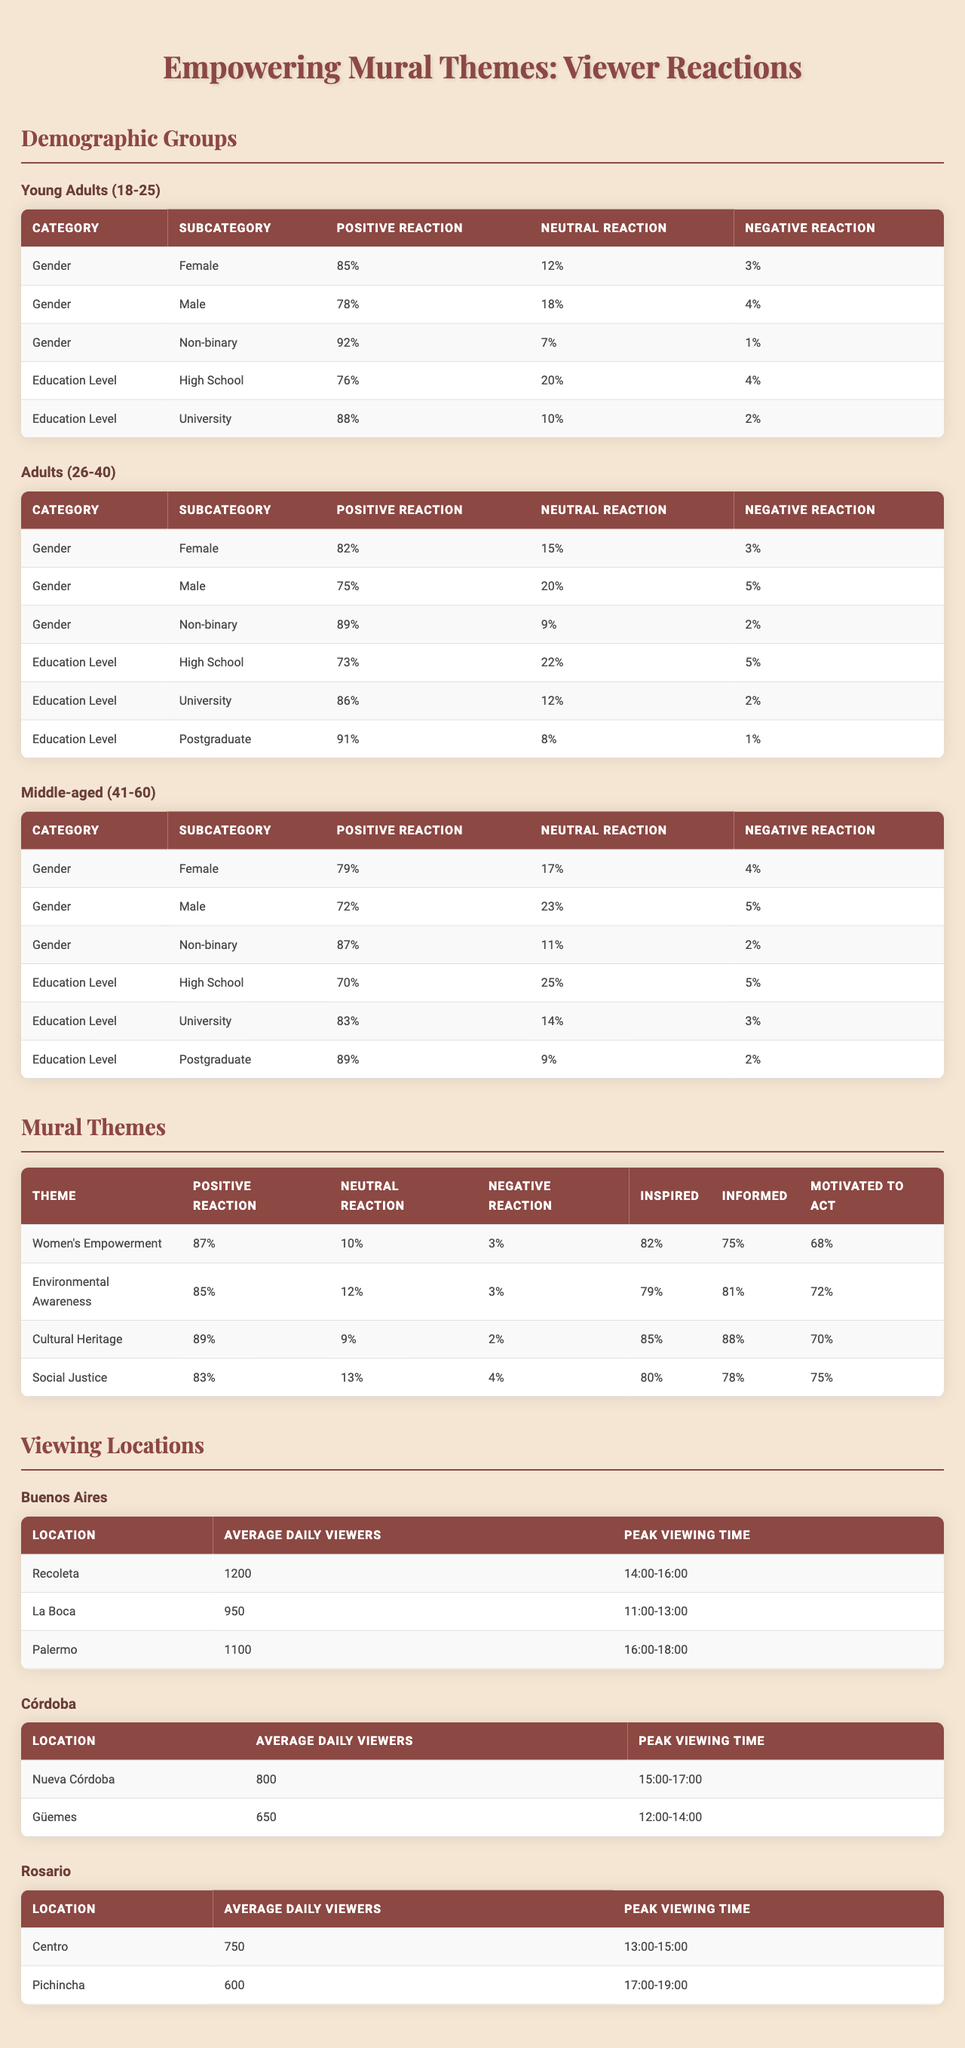What is the positive reaction percentage from non-binary viewers in the young adults demographic? For young adults (18-25), the positive reaction percentage for non-binary viewers is provided in the table and is 92%.
Answer: 92% Which age group shows the highest positive reaction for the theme of cultural heritage? The table indicates that the cultural heritage theme has a positive reaction of 89%, which is noted under the overall reactions with no breakdown by age group. Thus, it is the highest when compared with other themes.
Answer: 89% What is the peak viewing time for murals in Recoleta? The table specifies that the peak viewing time for Recoleta is from 14:00 to 16:00.
Answer: 14:00-16:00 Are positive reactions to the theme of environmental awareness higher than those for social justice among young adults? The positive reactions for young adults in the environmental awareness theme is 85%, whereas for social justice it is 83%. Therefore, yes, environmental awareness has higher positive reactions.
Answer: Yes What is the difference in positive reaction percentages between female and male viewers in the adults (26-40) demographic? From the table, the positive reactions for female viewers is 82%, and for male viewers is 75%. The difference is 82% - 75% = 7%.
Answer: 7% Which demographic group has the highest percentage of neutral reactions towards women's empowerment murals? By analyzing the demographics, the neutral reaction for young adult females is 12%, the highest compared to other demographics.
Answer: Young Adults (Females) How many viewers, on average, do murals in La Boca receive daily? The average daily viewers for murals in La Boca is listed as 950 in the table.
Answer: 950 In terms of overall reaction, how does the positive response to women’s empowerment compare to cultural heritage? Women's empowerment has a positive reaction of 87%, while cultural heritage has a positive reaction of 89%. Thus, cultural heritage has a slightly higher positive response by 2%.
Answer: Cultural Heritage is higher by 2% What percentage of middle-aged non-binary viewers had a negative reaction to empowering mural themes? For middle-aged viewers, the negative reaction for non-binary individuals is shown as 2% in the table.
Answer: 2% What is the average of positive reactions for university-educated viewers across all age groups? The positive reactions from university-educated viewers are: 88% (young adults), 86% (adults), and 83% (middle-aged). The average is (88 + 86 + 83) / 3 = 85.67%.
Answer: 85.67% 